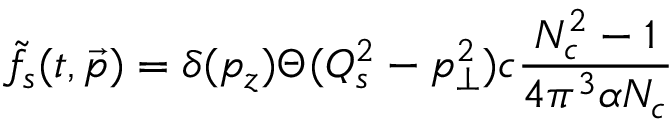<formula> <loc_0><loc_0><loc_500><loc_500>\tilde { f } _ { s } ( t , \vec { p } ) = \delta ( p _ { z } ) \Theta ( Q _ { s } ^ { 2 } - p _ { \perp } ^ { 2 } ) c { \frac { N _ { c } ^ { 2 } - 1 } { 4 \pi ^ { 3 } \alpha N _ { c } } }</formula> 